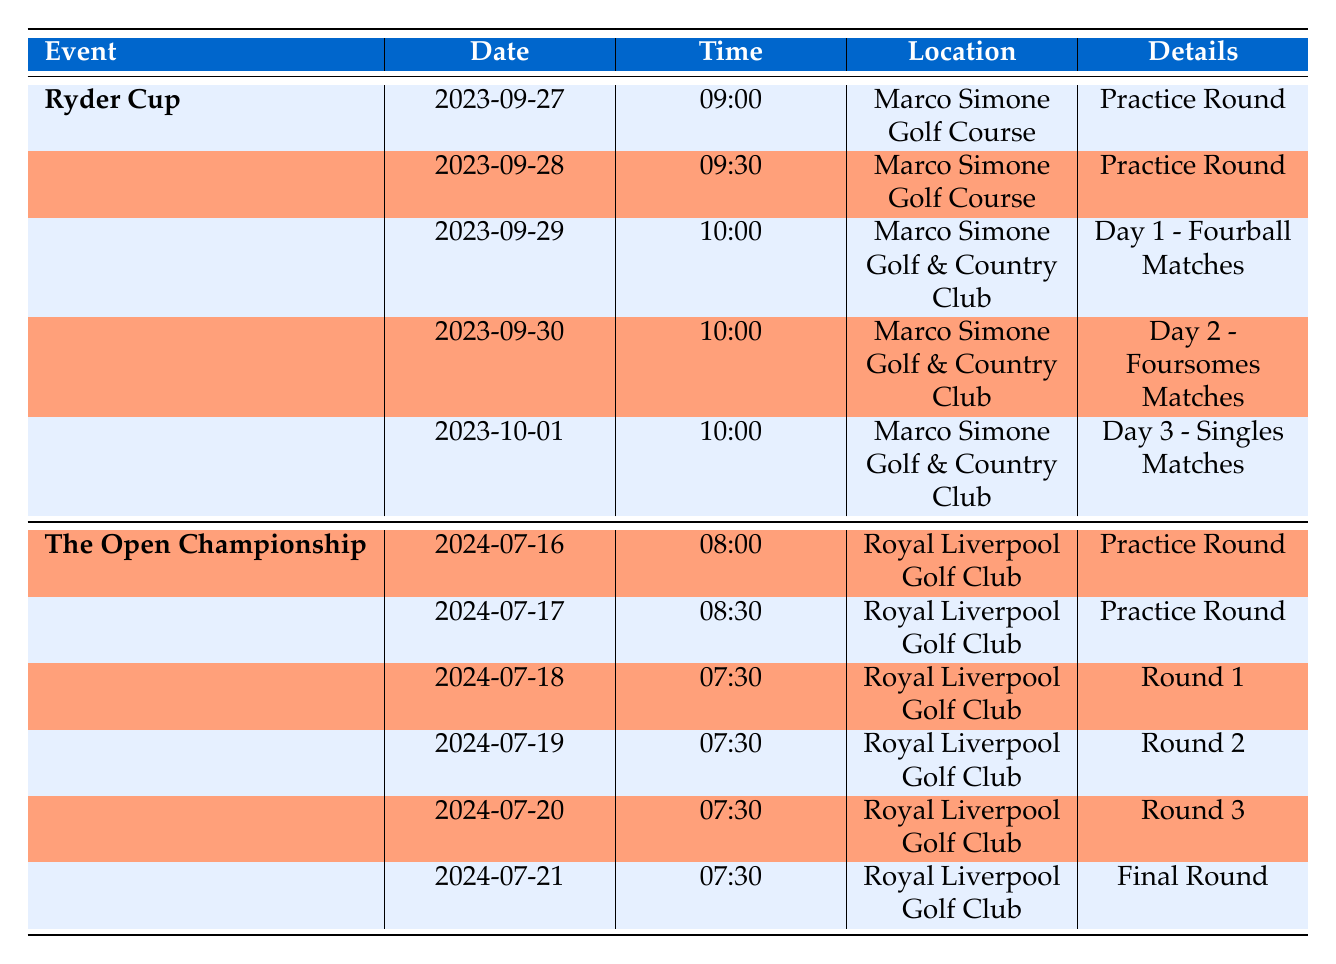What are the dates for the Ryder Cup? The Ryder Cup starts on September 29, 2023, and ends on October 1, 2023. This information is found in the "start_date" and "end_date" fields for the Ryder Cup entry in the table.
Answer: September 29, 2023 - October 1, 2023 What time does the first practice round for The Open Championship start? The first practice round for The Open Championship is on July 16, 2024, at 08:00. This is directly obtained from the "practice_rounds" section under the event entry for The Open Championship.
Answer: 08:00 Is there a practice round scheduled for the Ryder Cup on September 28, 2023? Yes, there is a practice round scheduled for the Ryder Cup on September 28, 2023, at 09:30. This is confirmed by checking the "practice_rounds" section for that date in the Ryder Cup entry.
Answer: Yes What is the total number of tournament days for The Open Championship? The Open Championship has four tournament days as listed in the "tournament_days" section, from July 18 to July 21, 2024. The number of entries in this section counts as the number of tournament days, hence 4.
Answer: 4 Which event has a practice round that starts earlier, the Ryder Cup or The Open Championship? The Ryder Cup has a practice round on September 27, 2023, starting at 09:00, while The Open Championship's first practice round starts at 08:00 on July 16, 2024. Since 08:00 is earlier than 09:00, The Open Championship starts earlier.
Answer: The Open Championship How many days are there between the end of the Ryder Cup and the start of The Open Championship? The Ryder Cup ends on October 1, 2023, and The Open Championship starts on July 18, 2024. To find the number of days between these two dates, we calculate the date range: from October 1, 2023, to July 18, 2024, is 290 days.
Answer: 290 days Does the schedule for The Open Championship include a final round? Yes, the schedule includes a final round on July 21, 2024. This can be verified by checking the "tournament_days" section of The Open Championship entry where the final round entry is listed.
Answer: Yes What is the duration of local transport for The Open Championship? The local transport for The Open Championship is a bicycle ride provided by "Cycle Liverpool," with a duration of 20 minutes. This detail is found in the "local_transport" section under the transport information for The Open Championship.
Answer: 20 minutes 